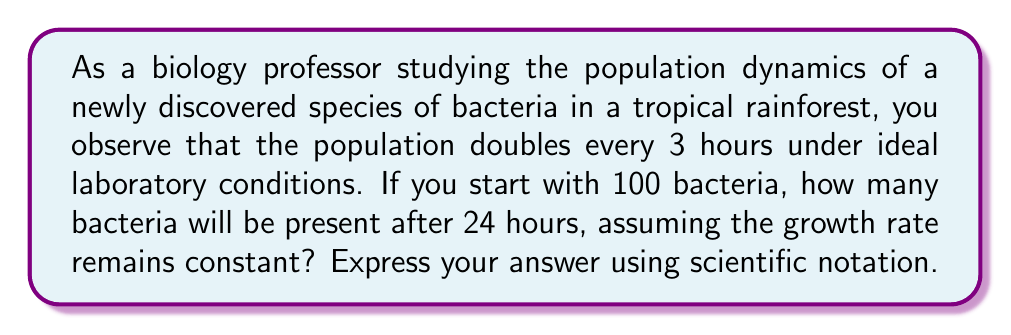Give your solution to this math problem. To solve this problem, we need to use the concept of geometric series and population growth rates. Let's break it down step-by-step:

1) First, we need to determine how many times the population doubles in 24 hours:
   $\frac{24 \text{ hours}}{3 \text{ hours per doubling}} = 8 \text{ doublings}$

2) We can represent this growth as a geometric sequence with:
   - Initial term $a = 100$ (initial population)
   - Common ratio $r = 2$ (population doubles each time)
   - Number of terms $n = 8 + 1 = 9$ (initial population plus 8 doublings)

3) The formula for the nth term of a geometric sequence is:
   $a_n = a \cdot r^{n-1}$

4) Substituting our values:
   $a_9 = 100 \cdot 2^{8}$

5) Calculate:
   $a_9 = 100 \cdot 256 = 25,600$

6) To express this in scientific notation:
   $25,600 = 2.56 \times 10^4$

Therefore, after 24 hours, the bacterial population will have grown to $2.56 \times 10^4$ individuals.
Answer: $2.56 \times 10^4$ bacteria 